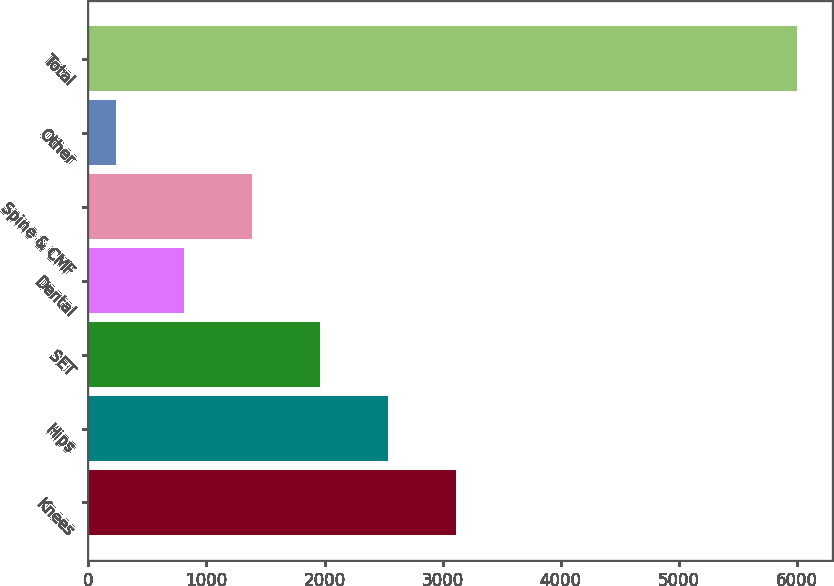Convert chart. <chart><loc_0><loc_0><loc_500><loc_500><bar_chart><fcel>Knees<fcel>Hips<fcel>SET<fcel>Dental<fcel>Spine & CMF<fcel>Other<fcel>Total<nl><fcel>3115.55<fcel>2539.1<fcel>1962.65<fcel>809.75<fcel>1386.2<fcel>233.3<fcel>5997.8<nl></chart> 